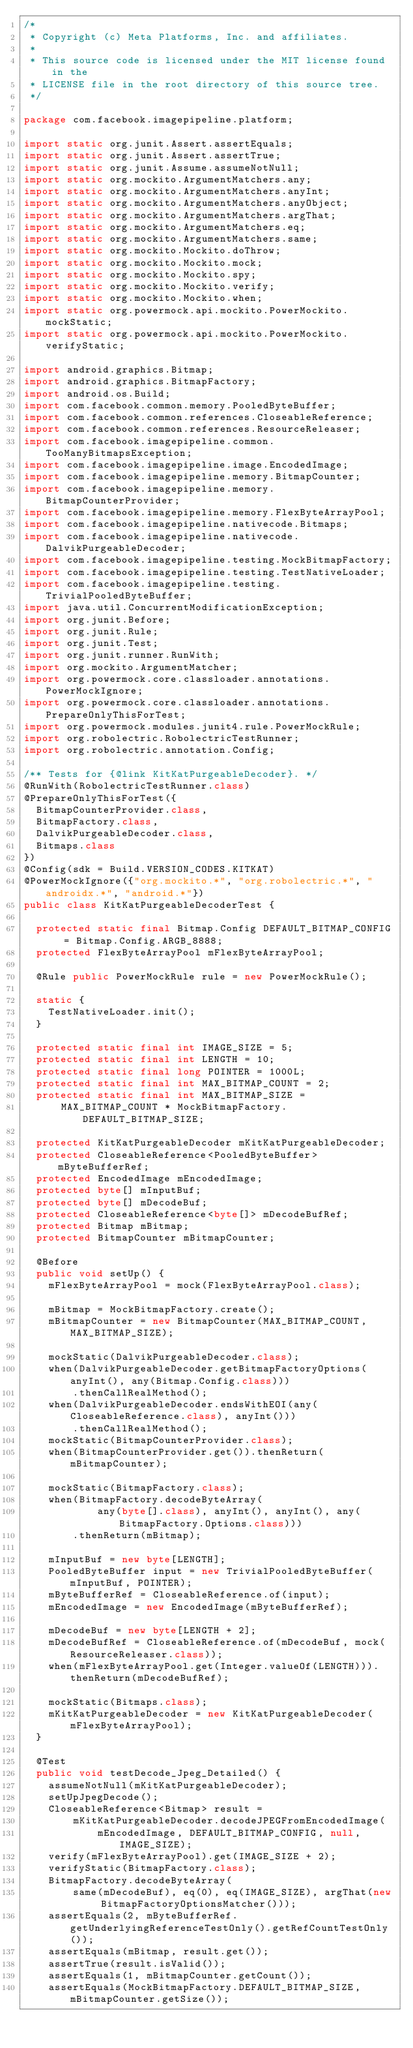<code> <loc_0><loc_0><loc_500><loc_500><_Java_>/*
 * Copyright (c) Meta Platforms, Inc. and affiliates.
 *
 * This source code is licensed under the MIT license found in the
 * LICENSE file in the root directory of this source tree.
 */

package com.facebook.imagepipeline.platform;

import static org.junit.Assert.assertEquals;
import static org.junit.Assert.assertTrue;
import static org.junit.Assume.assumeNotNull;
import static org.mockito.ArgumentMatchers.any;
import static org.mockito.ArgumentMatchers.anyInt;
import static org.mockito.ArgumentMatchers.anyObject;
import static org.mockito.ArgumentMatchers.argThat;
import static org.mockito.ArgumentMatchers.eq;
import static org.mockito.ArgumentMatchers.same;
import static org.mockito.Mockito.doThrow;
import static org.mockito.Mockito.mock;
import static org.mockito.Mockito.spy;
import static org.mockito.Mockito.verify;
import static org.mockito.Mockito.when;
import static org.powermock.api.mockito.PowerMockito.mockStatic;
import static org.powermock.api.mockito.PowerMockito.verifyStatic;

import android.graphics.Bitmap;
import android.graphics.BitmapFactory;
import android.os.Build;
import com.facebook.common.memory.PooledByteBuffer;
import com.facebook.common.references.CloseableReference;
import com.facebook.common.references.ResourceReleaser;
import com.facebook.imagepipeline.common.TooManyBitmapsException;
import com.facebook.imagepipeline.image.EncodedImage;
import com.facebook.imagepipeline.memory.BitmapCounter;
import com.facebook.imagepipeline.memory.BitmapCounterProvider;
import com.facebook.imagepipeline.memory.FlexByteArrayPool;
import com.facebook.imagepipeline.nativecode.Bitmaps;
import com.facebook.imagepipeline.nativecode.DalvikPurgeableDecoder;
import com.facebook.imagepipeline.testing.MockBitmapFactory;
import com.facebook.imagepipeline.testing.TestNativeLoader;
import com.facebook.imagepipeline.testing.TrivialPooledByteBuffer;
import java.util.ConcurrentModificationException;
import org.junit.Before;
import org.junit.Rule;
import org.junit.Test;
import org.junit.runner.RunWith;
import org.mockito.ArgumentMatcher;
import org.powermock.core.classloader.annotations.PowerMockIgnore;
import org.powermock.core.classloader.annotations.PrepareOnlyThisForTest;
import org.powermock.modules.junit4.rule.PowerMockRule;
import org.robolectric.RobolectricTestRunner;
import org.robolectric.annotation.Config;

/** Tests for {@link KitKatPurgeableDecoder}. */
@RunWith(RobolectricTestRunner.class)
@PrepareOnlyThisForTest({
  BitmapCounterProvider.class,
  BitmapFactory.class,
  DalvikPurgeableDecoder.class,
  Bitmaps.class
})
@Config(sdk = Build.VERSION_CODES.KITKAT)
@PowerMockIgnore({"org.mockito.*", "org.robolectric.*", "androidx.*", "android.*"})
public class KitKatPurgeableDecoderTest {

  protected static final Bitmap.Config DEFAULT_BITMAP_CONFIG = Bitmap.Config.ARGB_8888;
  protected FlexByteArrayPool mFlexByteArrayPool;

  @Rule public PowerMockRule rule = new PowerMockRule();

  static {
    TestNativeLoader.init();
  }

  protected static final int IMAGE_SIZE = 5;
  protected static final int LENGTH = 10;
  protected static final long POINTER = 1000L;
  protected static final int MAX_BITMAP_COUNT = 2;
  protected static final int MAX_BITMAP_SIZE =
      MAX_BITMAP_COUNT * MockBitmapFactory.DEFAULT_BITMAP_SIZE;

  protected KitKatPurgeableDecoder mKitKatPurgeableDecoder;
  protected CloseableReference<PooledByteBuffer> mByteBufferRef;
  protected EncodedImage mEncodedImage;
  protected byte[] mInputBuf;
  protected byte[] mDecodeBuf;
  protected CloseableReference<byte[]> mDecodeBufRef;
  protected Bitmap mBitmap;
  protected BitmapCounter mBitmapCounter;

  @Before
  public void setUp() {
    mFlexByteArrayPool = mock(FlexByteArrayPool.class);

    mBitmap = MockBitmapFactory.create();
    mBitmapCounter = new BitmapCounter(MAX_BITMAP_COUNT, MAX_BITMAP_SIZE);

    mockStatic(DalvikPurgeableDecoder.class);
    when(DalvikPurgeableDecoder.getBitmapFactoryOptions(anyInt(), any(Bitmap.Config.class)))
        .thenCallRealMethod();
    when(DalvikPurgeableDecoder.endsWithEOI(any(CloseableReference.class), anyInt()))
        .thenCallRealMethod();
    mockStatic(BitmapCounterProvider.class);
    when(BitmapCounterProvider.get()).thenReturn(mBitmapCounter);

    mockStatic(BitmapFactory.class);
    when(BitmapFactory.decodeByteArray(
            any(byte[].class), anyInt(), anyInt(), any(BitmapFactory.Options.class)))
        .thenReturn(mBitmap);

    mInputBuf = new byte[LENGTH];
    PooledByteBuffer input = new TrivialPooledByteBuffer(mInputBuf, POINTER);
    mByteBufferRef = CloseableReference.of(input);
    mEncodedImage = new EncodedImage(mByteBufferRef);

    mDecodeBuf = new byte[LENGTH + 2];
    mDecodeBufRef = CloseableReference.of(mDecodeBuf, mock(ResourceReleaser.class));
    when(mFlexByteArrayPool.get(Integer.valueOf(LENGTH))).thenReturn(mDecodeBufRef);

    mockStatic(Bitmaps.class);
    mKitKatPurgeableDecoder = new KitKatPurgeableDecoder(mFlexByteArrayPool);
  }

  @Test
  public void testDecode_Jpeg_Detailed() {
    assumeNotNull(mKitKatPurgeableDecoder);
    setUpJpegDecode();
    CloseableReference<Bitmap> result =
        mKitKatPurgeableDecoder.decodeJPEGFromEncodedImage(
            mEncodedImage, DEFAULT_BITMAP_CONFIG, null, IMAGE_SIZE);
    verify(mFlexByteArrayPool).get(IMAGE_SIZE + 2);
    verifyStatic(BitmapFactory.class);
    BitmapFactory.decodeByteArray(
        same(mDecodeBuf), eq(0), eq(IMAGE_SIZE), argThat(new BitmapFactoryOptionsMatcher()));
    assertEquals(2, mByteBufferRef.getUnderlyingReferenceTestOnly().getRefCountTestOnly());
    assertEquals(mBitmap, result.get());
    assertTrue(result.isValid());
    assertEquals(1, mBitmapCounter.getCount());
    assertEquals(MockBitmapFactory.DEFAULT_BITMAP_SIZE, mBitmapCounter.getSize());</code> 